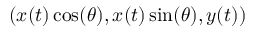<formula> <loc_0><loc_0><loc_500><loc_500>( x ( t ) \cos ( \theta ) , x ( t ) \sin ( \theta ) , y ( t ) )</formula> 